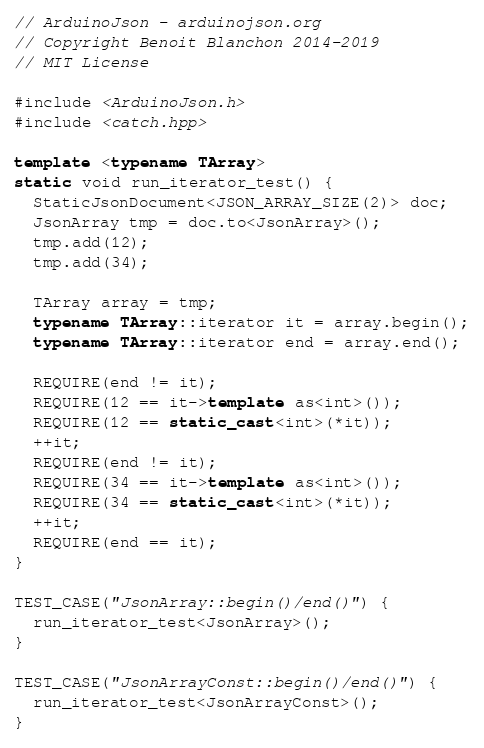Convert code to text. <code><loc_0><loc_0><loc_500><loc_500><_C++_>// ArduinoJson - arduinojson.org
// Copyright Benoit Blanchon 2014-2019
// MIT License

#include <ArduinoJson.h>
#include <catch.hpp>

template <typename TArray>
static void run_iterator_test() {
  StaticJsonDocument<JSON_ARRAY_SIZE(2)> doc;
  JsonArray tmp = doc.to<JsonArray>();
  tmp.add(12);
  tmp.add(34);

  TArray array = tmp;
  typename TArray::iterator it = array.begin();
  typename TArray::iterator end = array.end();

  REQUIRE(end != it);
  REQUIRE(12 == it->template as<int>());
  REQUIRE(12 == static_cast<int>(*it));
  ++it;
  REQUIRE(end != it);
  REQUIRE(34 == it->template as<int>());
  REQUIRE(34 == static_cast<int>(*it));
  ++it;
  REQUIRE(end == it);
}

TEST_CASE("JsonArray::begin()/end()") {
  run_iterator_test<JsonArray>();
}

TEST_CASE("JsonArrayConst::begin()/end()") {
  run_iterator_test<JsonArrayConst>();
}
</code> 